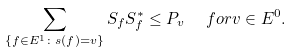Convert formula to latex. <formula><loc_0><loc_0><loc_500><loc_500>\sum _ { \{ f \in E ^ { 1 } \colon s ( f ) = v \} } S _ { f } S _ { f } ^ { * } \leq P _ { v } \ \ f o r v \in E ^ { 0 } .</formula> 